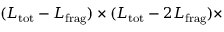<formula> <loc_0><loc_0><loc_500><loc_500>( L _ { t o t } - L _ { f r a g } ) \times ( L _ { t o t } - 2 L _ { f r a g } ) \times</formula> 